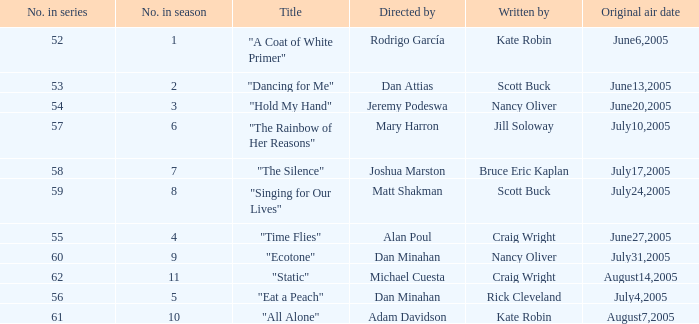What s the episode number in the season that was written by Nancy Oliver? 9.0. 